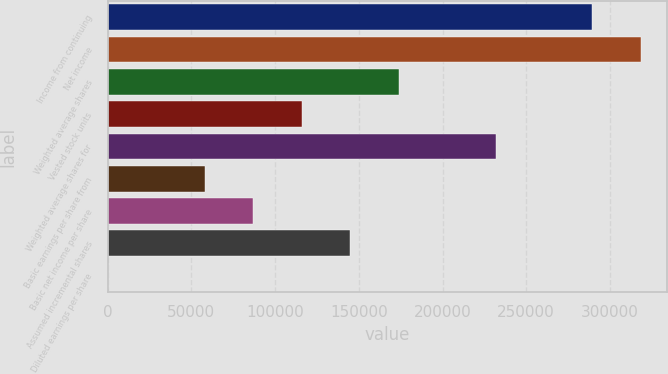<chart> <loc_0><loc_0><loc_500><loc_500><bar_chart><fcel>Income from continuing<fcel>Net income<fcel>Weighted average shares<fcel>Vested stock units<fcel>Weighted average shares for<fcel>Basic earnings per share from<fcel>Basic net income per share<fcel>Assumed incremental shares<fcel>Diluted earnings per share<nl><fcel>289329<fcel>318298<fcel>173816<fcel>115878<fcel>231753<fcel>57940.4<fcel>86909.2<fcel>144847<fcel>2.73<nl></chart> 